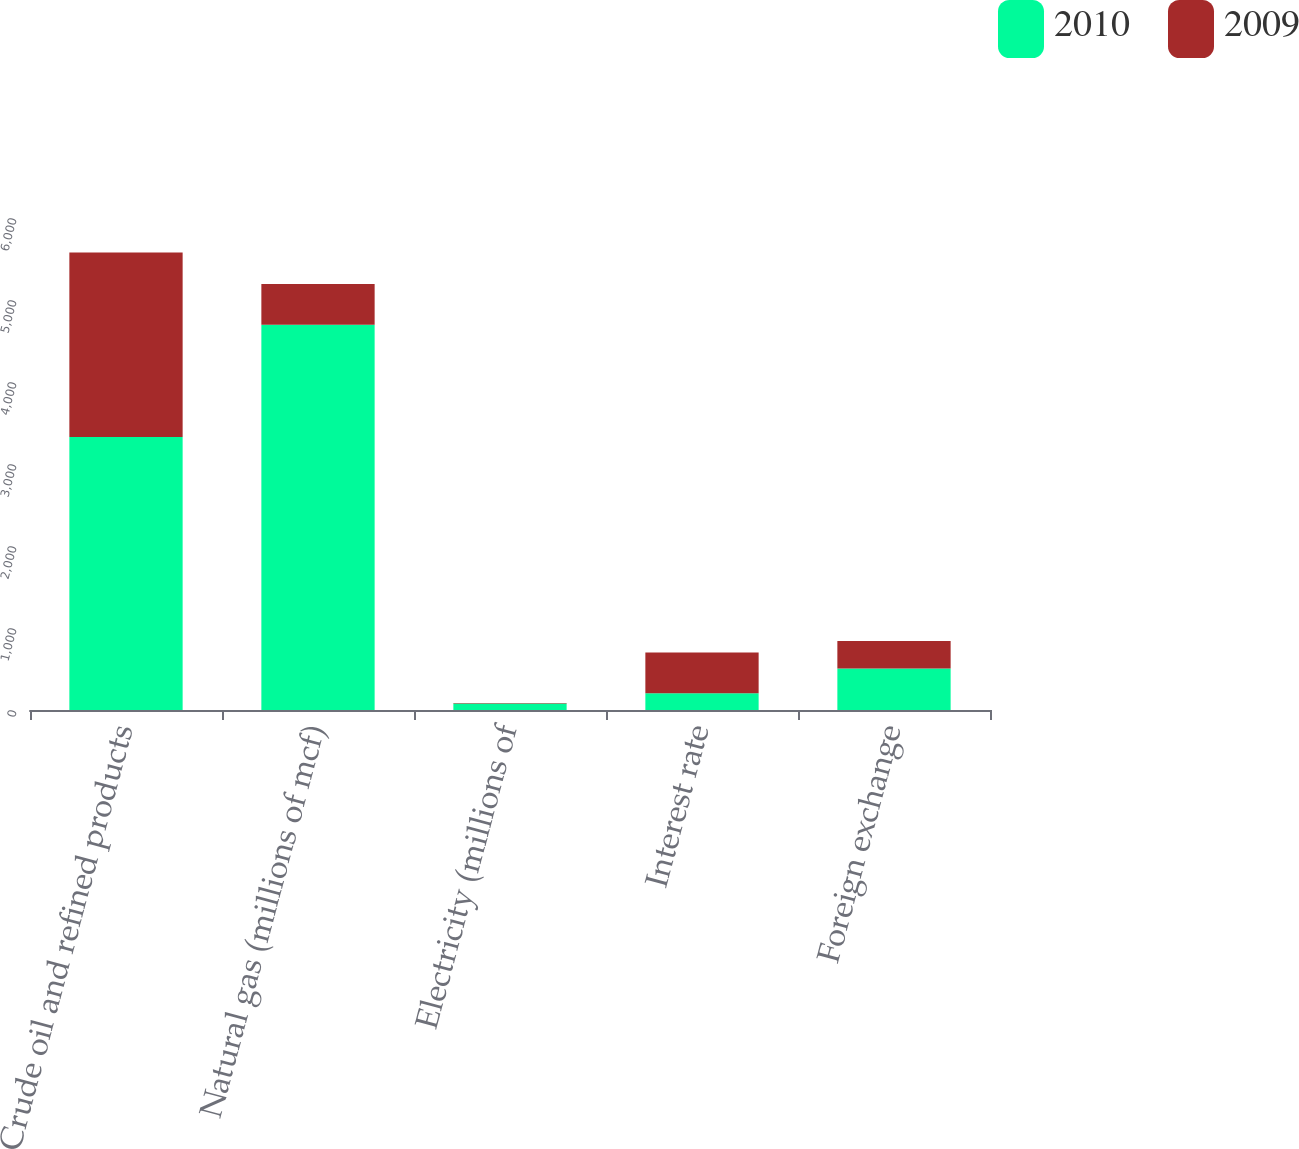<chart> <loc_0><loc_0><loc_500><loc_500><stacked_bar_chart><ecel><fcel>Crude oil and refined products<fcel>Natural gas (millions of mcf)<fcel>Electricity (millions of<fcel>Interest rate<fcel>Foreign exchange<nl><fcel>2010<fcel>3328<fcel>4699<fcel>79<fcel>205<fcel>506<nl><fcel>2009<fcel>2251<fcel>495<fcel>6<fcel>495<fcel>335<nl></chart> 